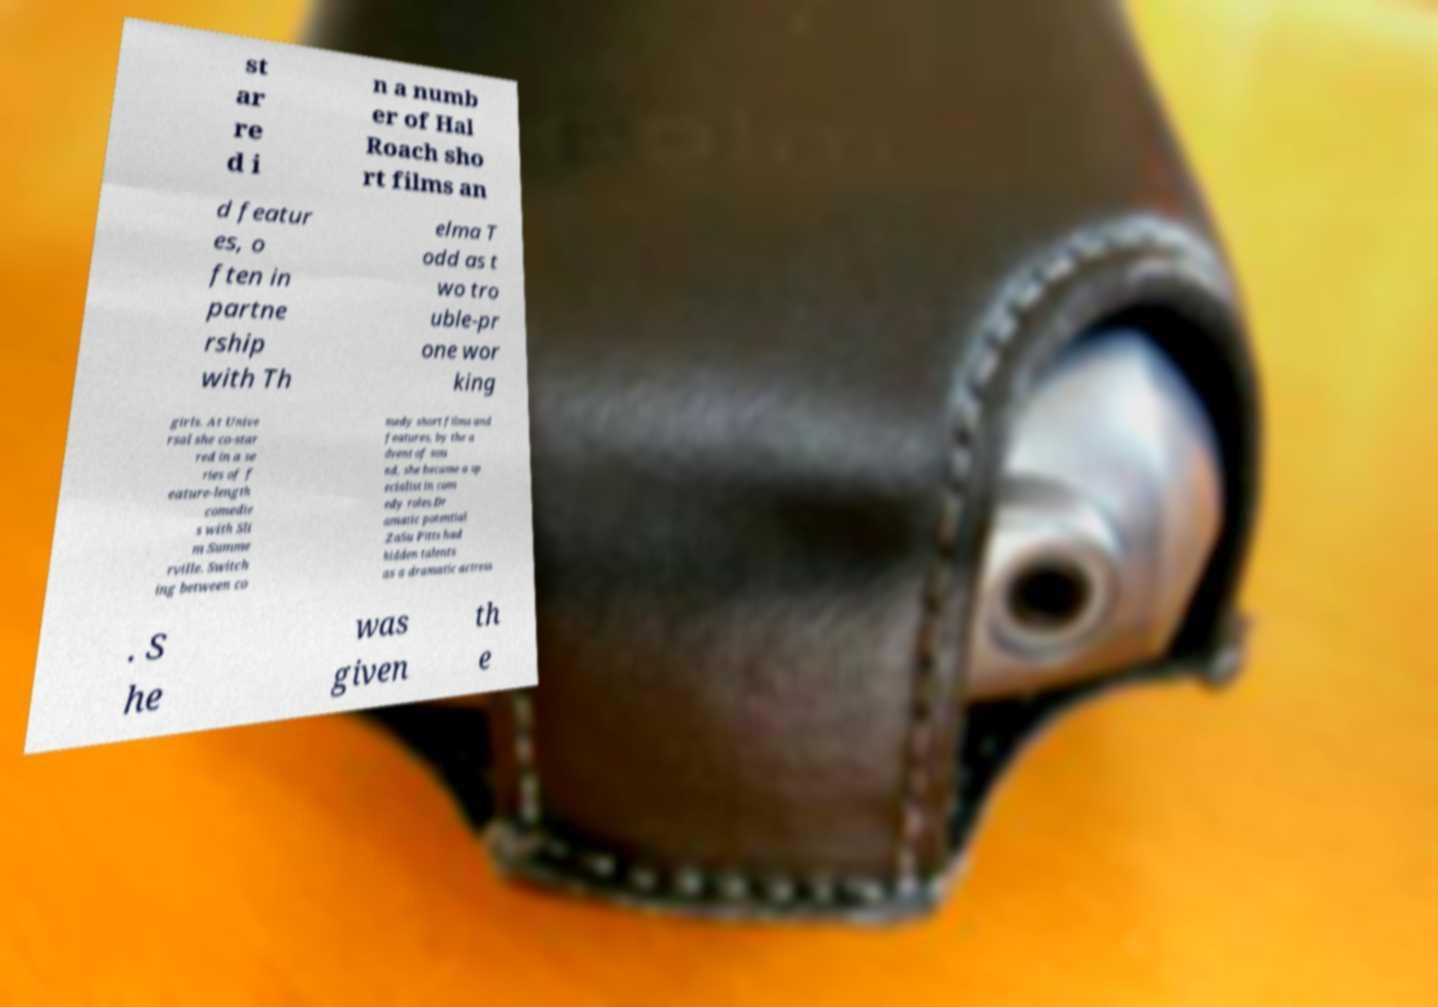There's text embedded in this image that I need extracted. Can you transcribe it verbatim? st ar re d i n a numb er of Hal Roach sho rt films an d featur es, o ften in partne rship with Th elma T odd as t wo tro uble-pr one wor king girls. At Unive rsal she co-star red in a se ries of f eature-length comedie s with Sli m Summe rville. Switch ing between co medy short films and features, by the a dvent of sou nd, she became a sp ecialist in com edy roles.Dr amatic potential .ZaSu Pitts had hidden talents as a dramatic actress . S he was given th e 